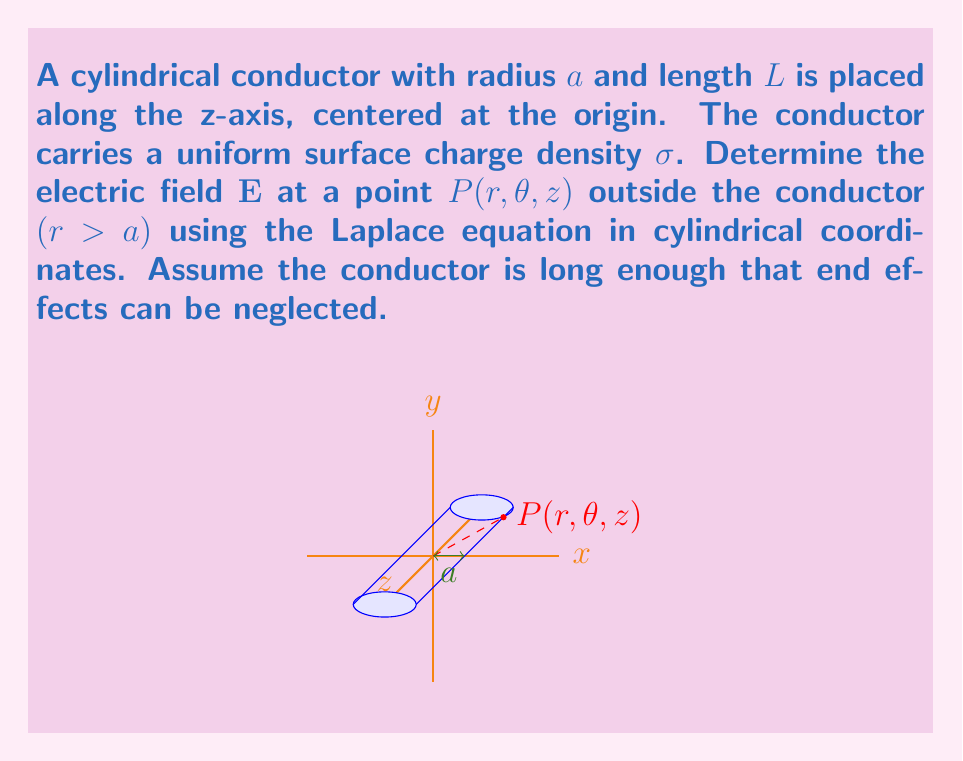Give your solution to this math problem. Let's solve this problem step by step:

1) In cylindrical coordinates, the Laplace equation for the electric potential $V$ is:

   $$\frac{1}{r}\frac{\partial}{\partial r}\left(r\frac{\partial V}{\partial r}\right) + \frac{1}{r^2}\frac{\partial^2 V}{\partial \theta^2} + \frac{\partial^2 V}{\partial z^2} = 0$$

2) Due to the cylindrical symmetry of the problem, $V$ is independent of $\theta$ and $z$. So, our equation simplifies to:

   $$\frac{1}{r}\frac{d}{dr}\left(r\frac{dV}{dr}\right) = 0$$

3) Integrating once:

   $$r\frac{dV}{dr} = C_1$$

4) Integrating again:

   $$V = C_1 \ln r + C_2$$

5) To find $C_1$ and $C_2$, we use boundary conditions:
   - At $r = a$, $V = V_0$ (some constant potential)
   - As $r \to \infty$, $V \to 0$

6) Applying these conditions:

   $$V_0 = C_1 \ln a + C_2$$
   $$0 = C_1 \ln \infty + C_2 \implies C_2 = 0$$

7) Solving for $C_1$:

   $$C_1 = \frac{V_0}{\ln a}$$

8) Therefore, the potential is:

   $$V = \frac{V_0}{\ln a} \ln r$$

9) The electric field is given by $\mathbf{E} = -\nabla V$. In cylindrical coordinates:

   $$\mathbf{E} = -\frac{\partial V}{\partial r}\hat{r} = -\frac{V_0}{r \ln a}\hat{r}$$

10) To relate $V_0$ to $\sigma$, we use Gauss's law:

    $$\oint \mathbf{E} \cdot d\mathbf{A} = \frac{Q}{\epsilon_0}$$

11) For a Gaussian cylinder of radius $r$ and length $L$:

    $$2\pi r L E = \frac{2\pi a L \sigma}{\epsilon_0}$$

12) Substituting $E = \frac{V_0}{r \ln a}$:

    $$\frac{2\pi L V_0}{\ln a} = \frac{2\pi a L \sigma}{\epsilon_0}$$

13) Solving for $V_0$:

    $$V_0 = \frac{a \sigma \ln a}{\epsilon_0}$$

14) Finally, substituting this back into our expression for $\mathbf{E}$:

    $$\mathbf{E} = \frac{a \sigma}{r \epsilon_0}\hat{r}$$
Answer: $$\mathbf{E} = \frac{a \sigma}{r \epsilon_0}\hat{r}$$ 